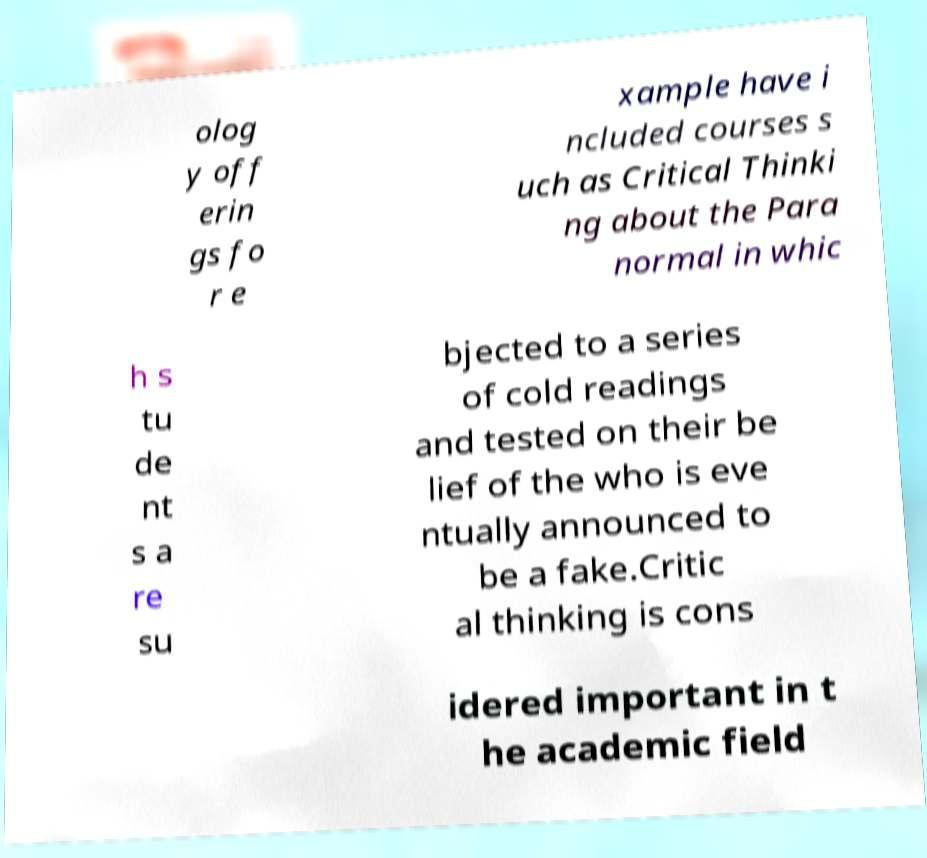Can you accurately transcribe the text from the provided image for me? olog y off erin gs fo r e xample have i ncluded courses s uch as Critical Thinki ng about the Para normal in whic h s tu de nt s a re su bjected to a series of cold readings and tested on their be lief of the who is eve ntually announced to be a fake.Critic al thinking is cons idered important in t he academic field 